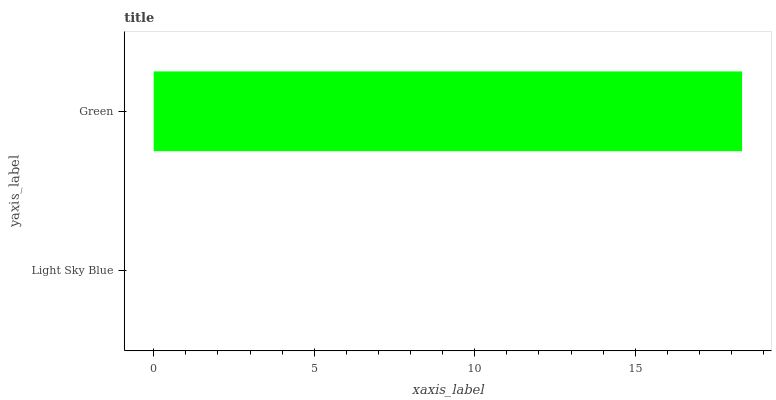Is Light Sky Blue the minimum?
Answer yes or no. Yes. Is Green the maximum?
Answer yes or no. Yes. Is Green the minimum?
Answer yes or no. No. Is Green greater than Light Sky Blue?
Answer yes or no. Yes. Is Light Sky Blue less than Green?
Answer yes or no. Yes. Is Light Sky Blue greater than Green?
Answer yes or no. No. Is Green less than Light Sky Blue?
Answer yes or no. No. Is Green the high median?
Answer yes or no. Yes. Is Light Sky Blue the low median?
Answer yes or no. Yes. Is Light Sky Blue the high median?
Answer yes or no. No. Is Green the low median?
Answer yes or no. No. 